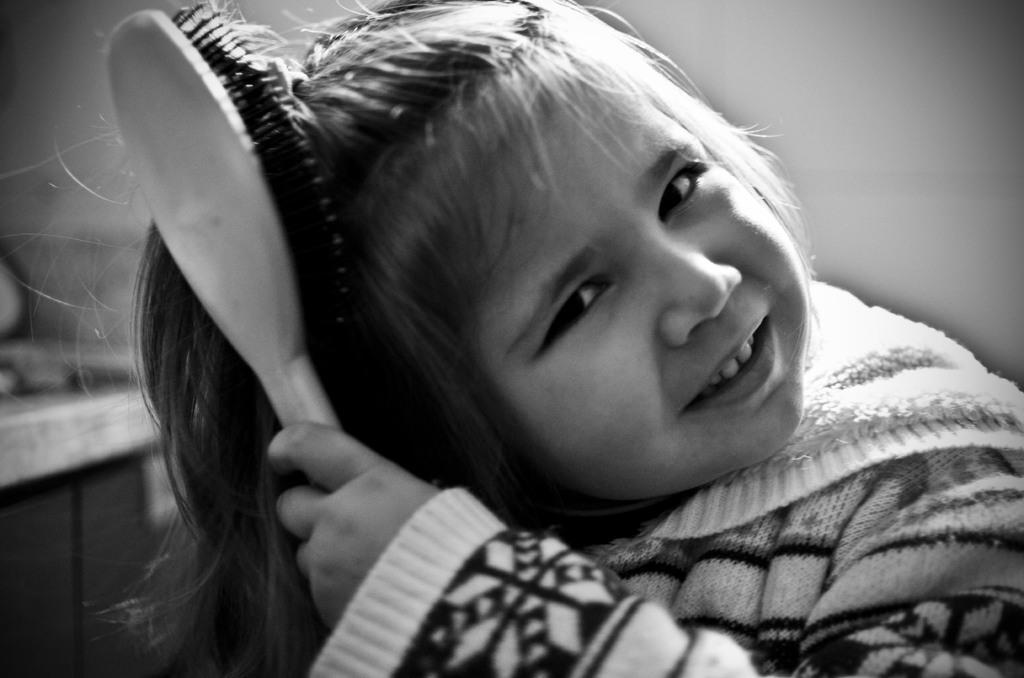Could you give a brief overview of what you see in this image? This is a black and white image, where a cute girl combing her hair. In the background, there is a wall. 